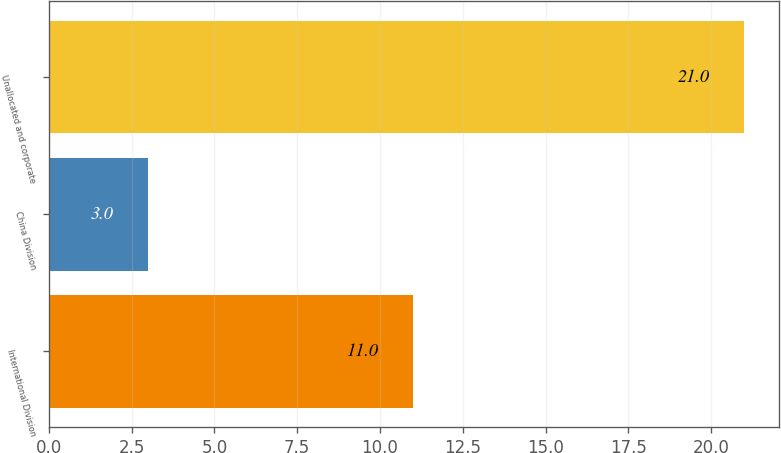<chart> <loc_0><loc_0><loc_500><loc_500><bar_chart><fcel>International Division<fcel>China Division<fcel>Unallocated and corporate<nl><fcel>11<fcel>3<fcel>21<nl></chart> 